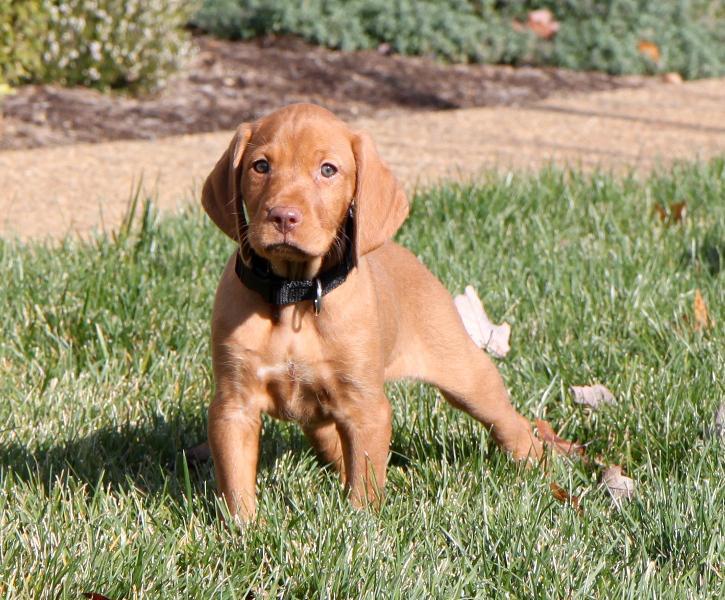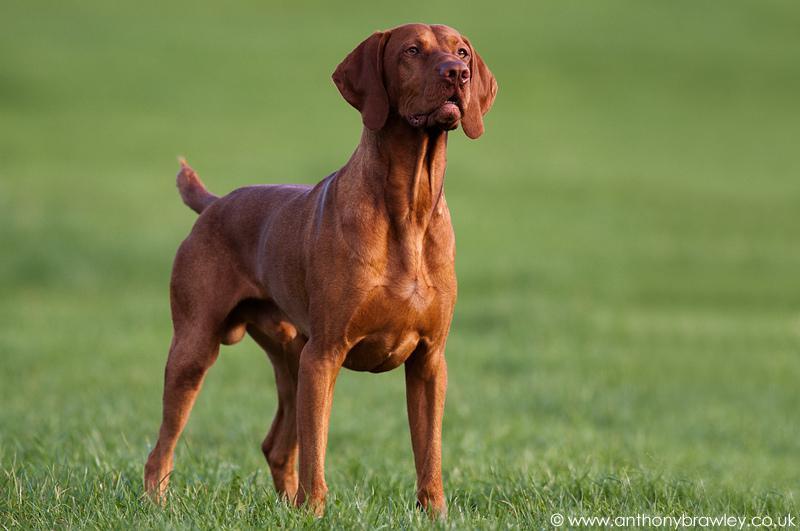The first image is the image on the left, the second image is the image on the right. For the images displayed, is the sentence "There are at least three puppies." factually correct? Answer yes or no. No. The first image is the image on the left, the second image is the image on the right. Assess this claim about the two images: "The right image shows one forward-looking puppy standing on grass with the front paw on the left raised.". Correct or not? Answer yes or no. No. 